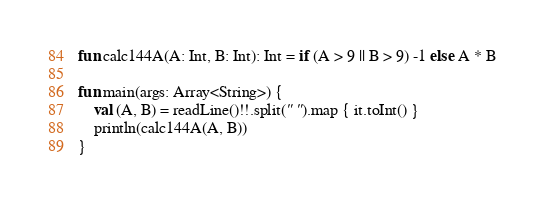<code> <loc_0><loc_0><loc_500><loc_500><_Kotlin_>fun calc144A(A: Int, B: Int): Int = if (A > 9 || B > 9) -1 else A * B

fun main(args: Array<String>) {
    val (A, B) = readLine()!!.split(" ").map { it.toInt() }
    println(calc144A(A, B))
}
</code> 